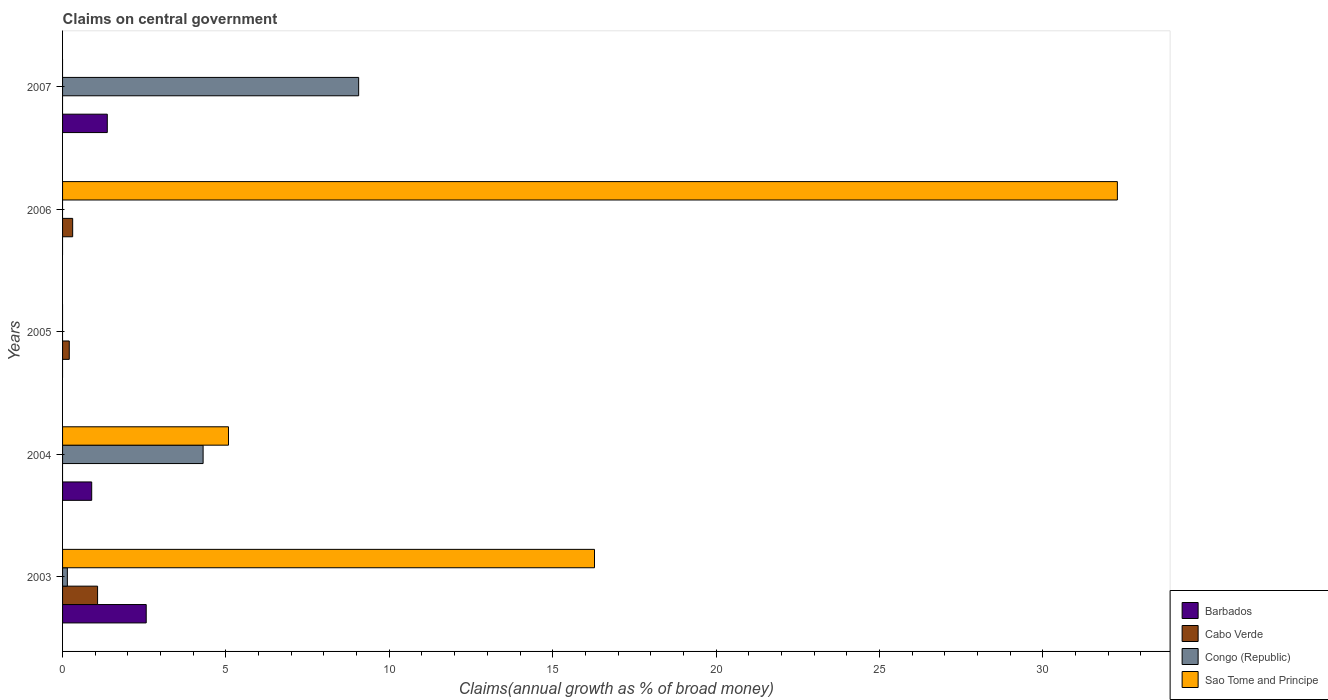How many bars are there on the 4th tick from the top?
Give a very brief answer. 3. What is the percentage of broad money claimed on centeral government in Barbados in 2004?
Give a very brief answer. 0.89. Across all years, what is the maximum percentage of broad money claimed on centeral government in Congo (Republic)?
Offer a very short reply. 9.06. Across all years, what is the minimum percentage of broad money claimed on centeral government in Barbados?
Offer a terse response. 0. In which year was the percentage of broad money claimed on centeral government in Cabo Verde maximum?
Ensure brevity in your answer.  2003. What is the total percentage of broad money claimed on centeral government in Cabo Verde in the graph?
Keep it short and to the point. 1.59. What is the difference between the percentage of broad money claimed on centeral government in Congo (Republic) in 2004 and that in 2007?
Make the answer very short. -4.76. What is the difference between the percentage of broad money claimed on centeral government in Sao Tome and Principe in 2004 and the percentage of broad money claimed on centeral government in Congo (Republic) in 2007?
Ensure brevity in your answer.  -3.98. What is the average percentage of broad money claimed on centeral government in Cabo Verde per year?
Your response must be concise. 0.32. In the year 2007, what is the difference between the percentage of broad money claimed on centeral government in Congo (Republic) and percentage of broad money claimed on centeral government in Barbados?
Your answer should be very brief. 7.69. In how many years, is the percentage of broad money claimed on centeral government in Cabo Verde greater than 11 %?
Provide a short and direct response. 0. What is the ratio of the percentage of broad money claimed on centeral government in Barbados in 2004 to that in 2007?
Give a very brief answer. 0.65. Is the percentage of broad money claimed on centeral government in Congo (Republic) in 2003 less than that in 2007?
Your answer should be compact. Yes. What is the difference between the highest and the second highest percentage of broad money claimed on centeral government in Barbados?
Your response must be concise. 1.19. What is the difference between the highest and the lowest percentage of broad money claimed on centeral government in Congo (Republic)?
Offer a very short reply. 9.06. In how many years, is the percentage of broad money claimed on centeral government in Barbados greater than the average percentage of broad money claimed on centeral government in Barbados taken over all years?
Ensure brevity in your answer.  2. Is it the case that in every year, the sum of the percentage of broad money claimed on centeral government in Cabo Verde and percentage of broad money claimed on centeral government in Barbados is greater than the sum of percentage of broad money claimed on centeral government in Sao Tome and Principe and percentage of broad money claimed on centeral government in Congo (Republic)?
Ensure brevity in your answer.  No. Is it the case that in every year, the sum of the percentage of broad money claimed on centeral government in Congo (Republic) and percentage of broad money claimed on centeral government in Cabo Verde is greater than the percentage of broad money claimed on centeral government in Barbados?
Give a very brief answer. No. How many bars are there?
Offer a very short reply. 12. Are all the bars in the graph horizontal?
Your answer should be very brief. Yes. What is the difference between two consecutive major ticks on the X-axis?
Provide a succinct answer. 5. Are the values on the major ticks of X-axis written in scientific E-notation?
Your response must be concise. No. Does the graph contain any zero values?
Provide a short and direct response. Yes. How many legend labels are there?
Your response must be concise. 4. What is the title of the graph?
Your response must be concise. Claims on central government. What is the label or title of the X-axis?
Ensure brevity in your answer.  Claims(annual growth as % of broad money). What is the label or title of the Y-axis?
Your response must be concise. Years. What is the Claims(annual growth as % of broad money) in Barbados in 2003?
Make the answer very short. 2.56. What is the Claims(annual growth as % of broad money) of Cabo Verde in 2003?
Your response must be concise. 1.07. What is the Claims(annual growth as % of broad money) in Congo (Republic) in 2003?
Your answer should be very brief. 0.15. What is the Claims(annual growth as % of broad money) of Sao Tome and Principe in 2003?
Provide a short and direct response. 16.28. What is the Claims(annual growth as % of broad money) in Barbados in 2004?
Provide a succinct answer. 0.89. What is the Claims(annual growth as % of broad money) of Cabo Verde in 2004?
Keep it short and to the point. 0. What is the Claims(annual growth as % of broad money) in Congo (Republic) in 2004?
Make the answer very short. 4.3. What is the Claims(annual growth as % of broad money) in Sao Tome and Principe in 2004?
Provide a succinct answer. 5.08. What is the Claims(annual growth as % of broad money) in Barbados in 2005?
Provide a short and direct response. 0. What is the Claims(annual growth as % of broad money) of Cabo Verde in 2005?
Keep it short and to the point. 0.21. What is the Claims(annual growth as % of broad money) in Congo (Republic) in 2005?
Your answer should be very brief. 0. What is the Claims(annual growth as % of broad money) of Sao Tome and Principe in 2005?
Your answer should be very brief. 0. What is the Claims(annual growth as % of broad money) in Cabo Verde in 2006?
Offer a very short reply. 0.31. What is the Claims(annual growth as % of broad money) of Congo (Republic) in 2006?
Provide a succinct answer. 0. What is the Claims(annual growth as % of broad money) in Sao Tome and Principe in 2006?
Give a very brief answer. 32.28. What is the Claims(annual growth as % of broad money) in Barbados in 2007?
Your response must be concise. 1.37. What is the Claims(annual growth as % of broad money) in Cabo Verde in 2007?
Provide a succinct answer. 0. What is the Claims(annual growth as % of broad money) in Congo (Republic) in 2007?
Offer a very short reply. 9.06. Across all years, what is the maximum Claims(annual growth as % of broad money) of Barbados?
Offer a very short reply. 2.56. Across all years, what is the maximum Claims(annual growth as % of broad money) of Cabo Verde?
Offer a very short reply. 1.07. Across all years, what is the maximum Claims(annual growth as % of broad money) in Congo (Republic)?
Provide a short and direct response. 9.06. Across all years, what is the maximum Claims(annual growth as % of broad money) of Sao Tome and Principe?
Offer a terse response. 32.28. Across all years, what is the minimum Claims(annual growth as % of broad money) in Barbados?
Make the answer very short. 0. Across all years, what is the minimum Claims(annual growth as % of broad money) in Cabo Verde?
Provide a succinct answer. 0. What is the total Claims(annual growth as % of broad money) in Barbados in the graph?
Your response must be concise. 4.82. What is the total Claims(annual growth as % of broad money) in Cabo Verde in the graph?
Your answer should be compact. 1.59. What is the total Claims(annual growth as % of broad money) of Congo (Republic) in the graph?
Your answer should be compact. 13.51. What is the total Claims(annual growth as % of broad money) in Sao Tome and Principe in the graph?
Your response must be concise. 53.64. What is the difference between the Claims(annual growth as % of broad money) in Barbados in 2003 and that in 2004?
Offer a terse response. 1.67. What is the difference between the Claims(annual growth as % of broad money) of Congo (Republic) in 2003 and that in 2004?
Provide a succinct answer. -4.15. What is the difference between the Claims(annual growth as % of broad money) in Sao Tome and Principe in 2003 and that in 2004?
Make the answer very short. 11.2. What is the difference between the Claims(annual growth as % of broad money) of Cabo Verde in 2003 and that in 2005?
Provide a short and direct response. 0.87. What is the difference between the Claims(annual growth as % of broad money) in Cabo Verde in 2003 and that in 2006?
Your response must be concise. 0.76. What is the difference between the Claims(annual growth as % of broad money) in Sao Tome and Principe in 2003 and that in 2006?
Offer a terse response. -16. What is the difference between the Claims(annual growth as % of broad money) in Barbados in 2003 and that in 2007?
Your answer should be very brief. 1.19. What is the difference between the Claims(annual growth as % of broad money) of Congo (Republic) in 2003 and that in 2007?
Your answer should be compact. -8.92. What is the difference between the Claims(annual growth as % of broad money) of Sao Tome and Principe in 2004 and that in 2006?
Keep it short and to the point. -27.21. What is the difference between the Claims(annual growth as % of broad money) of Barbados in 2004 and that in 2007?
Your answer should be very brief. -0.48. What is the difference between the Claims(annual growth as % of broad money) of Congo (Republic) in 2004 and that in 2007?
Provide a succinct answer. -4.76. What is the difference between the Claims(annual growth as % of broad money) of Cabo Verde in 2005 and that in 2006?
Your answer should be compact. -0.1. What is the difference between the Claims(annual growth as % of broad money) of Barbados in 2003 and the Claims(annual growth as % of broad money) of Congo (Republic) in 2004?
Your answer should be very brief. -1.74. What is the difference between the Claims(annual growth as % of broad money) of Barbados in 2003 and the Claims(annual growth as % of broad money) of Sao Tome and Principe in 2004?
Your response must be concise. -2.52. What is the difference between the Claims(annual growth as % of broad money) of Cabo Verde in 2003 and the Claims(annual growth as % of broad money) of Congo (Republic) in 2004?
Keep it short and to the point. -3.23. What is the difference between the Claims(annual growth as % of broad money) in Cabo Verde in 2003 and the Claims(annual growth as % of broad money) in Sao Tome and Principe in 2004?
Your answer should be very brief. -4.01. What is the difference between the Claims(annual growth as % of broad money) of Congo (Republic) in 2003 and the Claims(annual growth as % of broad money) of Sao Tome and Principe in 2004?
Give a very brief answer. -4.93. What is the difference between the Claims(annual growth as % of broad money) in Barbados in 2003 and the Claims(annual growth as % of broad money) in Cabo Verde in 2005?
Give a very brief answer. 2.36. What is the difference between the Claims(annual growth as % of broad money) of Barbados in 2003 and the Claims(annual growth as % of broad money) of Cabo Verde in 2006?
Your answer should be very brief. 2.25. What is the difference between the Claims(annual growth as % of broad money) of Barbados in 2003 and the Claims(annual growth as % of broad money) of Sao Tome and Principe in 2006?
Your answer should be very brief. -29.72. What is the difference between the Claims(annual growth as % of broad money) of Cabo Verde in 2003 and the Claims(annual growth as % of broad money) of Sao Tome and Principe in 2006?
Offer a terse response. -31.21. What is the difference between the Claims(annual growth as % of broad money) in Congo (Republic) in 2003 and the Claims(annual growth as % of broad money) in Sao Tome and Principe in 2006?
Give a very brief answer. -32.14. What is the difference between the Claims(annual growth as % of broad money) in Barbados in 2003 and the Claims(annual growth as % of broad money) in Congo (Republic) in 2007?
Your answer should be very brief. -6.5. What is the difference between the Claims(annual growth as % of broad money) of Cabo Verde in 2003 and the Claims(annual growth as % of broad money) of Congo (Republic) in 2007?
Offer a very short reply. -7.99. What is the difference between the Claims(annual growth as % of broad money) of Barbados in 2004 and the Claims(annual growth as % of broad money) of Cabo Verde in 2005?
Ensure brevity in your answer.  0.69. What is the difference between the Claims(annual growth as % of broad money) of Barbados in 2004 and the Claims(annual growth as % of broad money) of Cabo Verde in 2006?
Your answer should be compact. 0.58. What is the difference between the Claims(annual growth as % of broad money) of Barbados in 2004 and the Claims(annual growth as % of broad money) of Sao Tome and Principe in 2006?
Provide a short and direct response. -31.39. What is the difference between the Claims(annual growth as % of broad money) of Congo (Republic) in 2004 and the Claims(annual growth as % of broad money) of Sao Tome and Principe in 2006?
Provide a succinct answer. -27.98. What is the difference between the Claims(annual growth as % of broad money) in Barbados in 2004 and the Claims(annual growth as % of broad money) in Congo (Republic) in 2007?
Your response must be concise. -8.17. What is the difference between the Claims(annual growth as % of broad money) of Cabo Verde in 2005 and the Claims(annual growth as % of broad money) of Sao Tome and Principe in 2006?
Offer a terse response. -32.08. What is the difference between the Claims(annual growth as % of broad money) in Cabo Verde in 2005 and the Claims(annual growth as % of broad money) in Congo (Republic) in 2007?
Keep it short and to the point. -8.86. What is the difference between the Claims(annual growth as % of broad money) in Cabo Verde in 2006 and the Claims(annual growth as % of broad money) in Congo (Republic) in 2007?
Keep it short and to the point. -8.75. What is the average Claims(annual growth as % of broad money) of Barbados per year?
Offer a terse response. 0.96. What is the average Claims(annual growth as % of broad money) of Cabo Verde per year?
Your answer should be compact. 0.32. What is the average Claims(annual growth as % of broad money) of Congo (Republic) per year?
Offer a terse response. 2.7. What is the average Claims(annual growth as % of broad money) in Sao Tome and Principe per year?
Offer a very short reply. 10.73. In the year 2003, what is the difference between the Claims(annual growth as % of broad money) of Barbados and Claims(annual growth as % of broad money) of Cabo Verde?
Offer a terse response. 1.49. In the year 2003, what is the difference between the Claims(annual growth as % of broad money) in Barbados and Claims(annual growth as % of broad money) in Congo (Republic)?
Offer a very short reply. 2.41. In the year 2003, what is the difference between the Claims(annual growth as % of broad money) in Barbados and Claims(annual growth as % of broad money) in Sao Tome and Principe?
Ensure brevity in your answer.  -13.72. In the year 2003, what is the difference between the Claims(annual growth as % of broad money) in Cabo Verde and Claims(annual growth as % of broad money) in Congo (Republic)?
Make the answer very short. 0.92. In the year 2003, what is the difference between the Claims(annual growth as % of broad money) of Cabo Verde and Claims(annual growth as % of broad money) of Sao Tome and Principe?
Your response must be concise. -15.21. In the year 2003, what is the difference between the Claims(annual growth as % of broad money) in Congo (Republic) and Claims(annual growth as % of broad money) in Sao Tome and Principe?
Provide a succinct answer. -16.13. In the year 2004, what is the difference between the Claims(annual growth as % of broad money) of Barbados and Claims(annual growth as % of broad money) of Congo (Republic)?
Your answer should be very brief. -3.41. In the year 2004, what is the difference between the Claims(annual growth as % of broad money) of Barbados and Claims(annual growth as % of broad money) of Sao Tome and Principe?
Your answer should be very brief. -4.19. In the year 2004, what is the difference between the Claims(annual growth as % of broad money) in Congo (Republic) and Claims(annual growth as % of broad money) in Sao Tome and Principe?
Offer a very short reply. -0.78. In the year 2006, what is the difference between the Claims(annual growth as % of broad money) in Cabo Verde and Claims(annual growth as % of broad money) in Sao Tome and Principe?
Give a very brief answer. -31.97. In the year 2007, what is the difference between the Claims(annual growth as % of broad money) of Barbados and Claims(annual growth as % of broad money) of Congo (Republic)?
Make the answer very short. -7.69. What is the ratio of the Claims(annual growth as % of broad money) in Barbados in 2003 to that in 2004?
Ensure brevity in your answer.  2.87. What is the ratio of the Claims(annual growth as % of broad money) in Congo (Republic) in 2003 to that in 2004?
Offer a very short reply. 0.03. What is the ratio of the Claims(annual growth as % of broad money) in Sao Tome and Principe in 2003 to that in 2004?
Keep it short and to the point. 3.21. What is the ratio of the Claims(annual growth as % of broad money) of Cabo Verde in 2003 to that in 2005?
Offer a terse response. 5.22. What is the ratio of the Claims(annual growth as % of broad money) in Cabo Verde in 2003 to that in 2006?
Offer a very short reply. 3.46. What is the ratio of the Claims(annual growth as % of broad money) in Sao Tome and Principe in 2003 to that in 2006?
Your answer should be very brief. 0.5. What is the ratio of the Claims(annual growth as % of broad money) in Barbados in 2003 to that in 2007?
Keep it short and to the point. 1.87. What is the ratio of the Claims(annual growth as % of broad money) of Congo (Republic) in 2003 to that in 2007?
Your answer should be compact. 0.02. What is the ratio of the Claims(annual growth as % of broad money) of Sao Tome and Principe in 2004 to that in 2006?
Offer a very short reply. 0.16. What is the ratio of the Claims(annual growth as % of broad money) in Barbados in 2004 to that in 2007?
Your answer should be compact. 0.65. What is the ratio of the Claims(annual growth as % of broad money) in Congo (Republic) in 2004 to that in 2007?
Provide a succinct answer. 0.47. What is the ratio of the Claims(annual growth as % of broad money) of Cabo Verde in 2005 to that in 2006?
Provide a succinct answer. 0.66. What is the difference between the highest and the second highest Claims(annual growth as % of broad money) in Barbados?
Keep it short and to the point. 1.19. What is the difference between the highest and the second highest Claims(annual growth as % of broad money) of Cabo Verde?
Provide a short and direct response. 0.76. What is the difference between the highest and the second highest Claims(annual growth as % of broad money) in Congo (Republic)?
Keep it short and to the point. 4.76. What is the difference between the highest and the second highest Claims(annual growth as % of broad money) in Sao Tome and Principe?
Offer a very short reply. 16. What is the difference between the highest and the lowest Claims(annual growth as % of broad money) in Barbados?
Your response must be concise. 2.56. What is the difference between the highest and the lowest Claims(annual growth as % of broad money) in Cabo Verde?
Your response must be concise. 1.07. What is the difference between the highest and the lowest Claims(annual growth as % of broad money) of Congo (Republic)?
Offer a terse response. 9.06. What is the difference between the highest and the lowest Claims(annual growth as % of broad money) in Sao Tome and Principe?
Offer a very short reply. 32.28. 